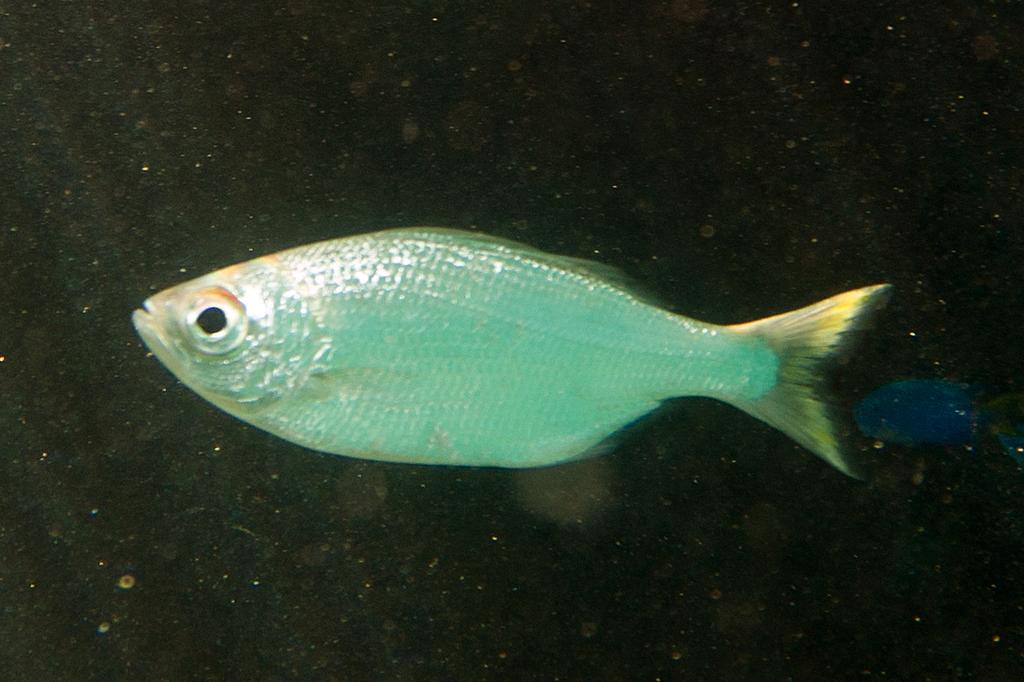What is the primary element visible in the image? There is water in the image. What type of animals can be seen in the water? There are fish in the image. What type of spark can be seen on the fish's ear in the image? There is no spark or ear present on the fish in the image. 